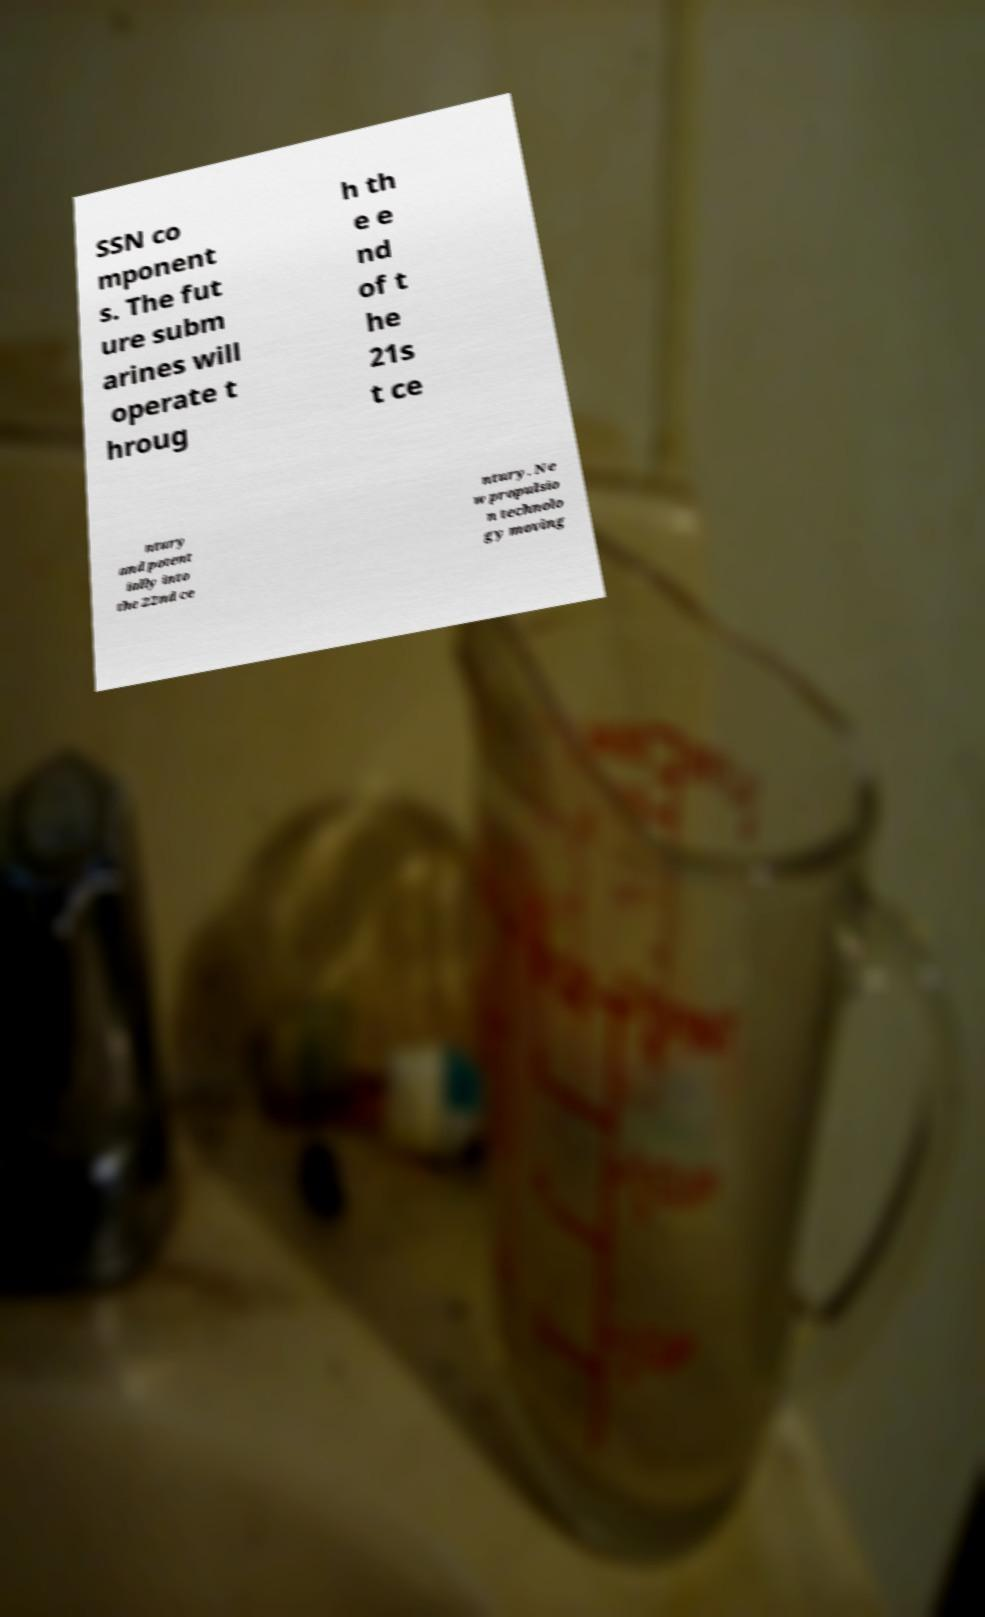Could you assist in decoding the text presented in this image and type it out clearly? SSN co mponent s. The fut ure subm arines will operate t hroug h th e e nd of t he 21s t ce ntury and potent ially into the 22nd ce ntury. Ne w propulsio n technolo gy moving 